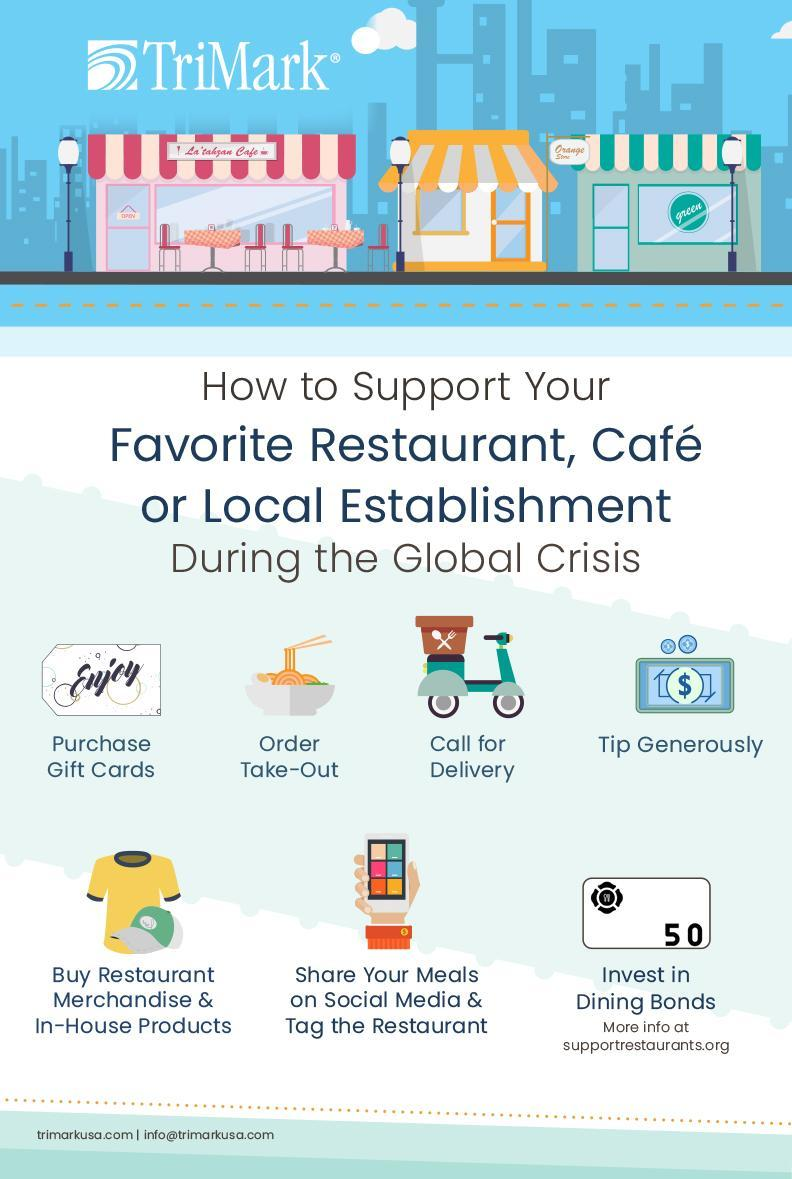How many restaurants/cafes are shown in the image?
Answer the question with a short phrase. 3 What is 4th method mentioned? Tip generously What is the colour of the t-shirt shown- blue, pink, red or yellow? Yellow Which currency note is shown in the image - dollar, pound or rupee? Dollar What other merchandise is shown along with the t-shirt - pen, cap or book? Cap How many methods of supporting are mentioned? 7 Which method is represented by the image of a bowl of food? Order take-out What is the last method shown here? Invest in dining bonds Which method is represented by the image of a scooter? Call for delivery What is the second last method shown here? Share your meals on social media & tag the restaurant What are the first three methods? Purchase gift cards, order take-out, call for delivery What is the number written on the image representing the last method? 50 